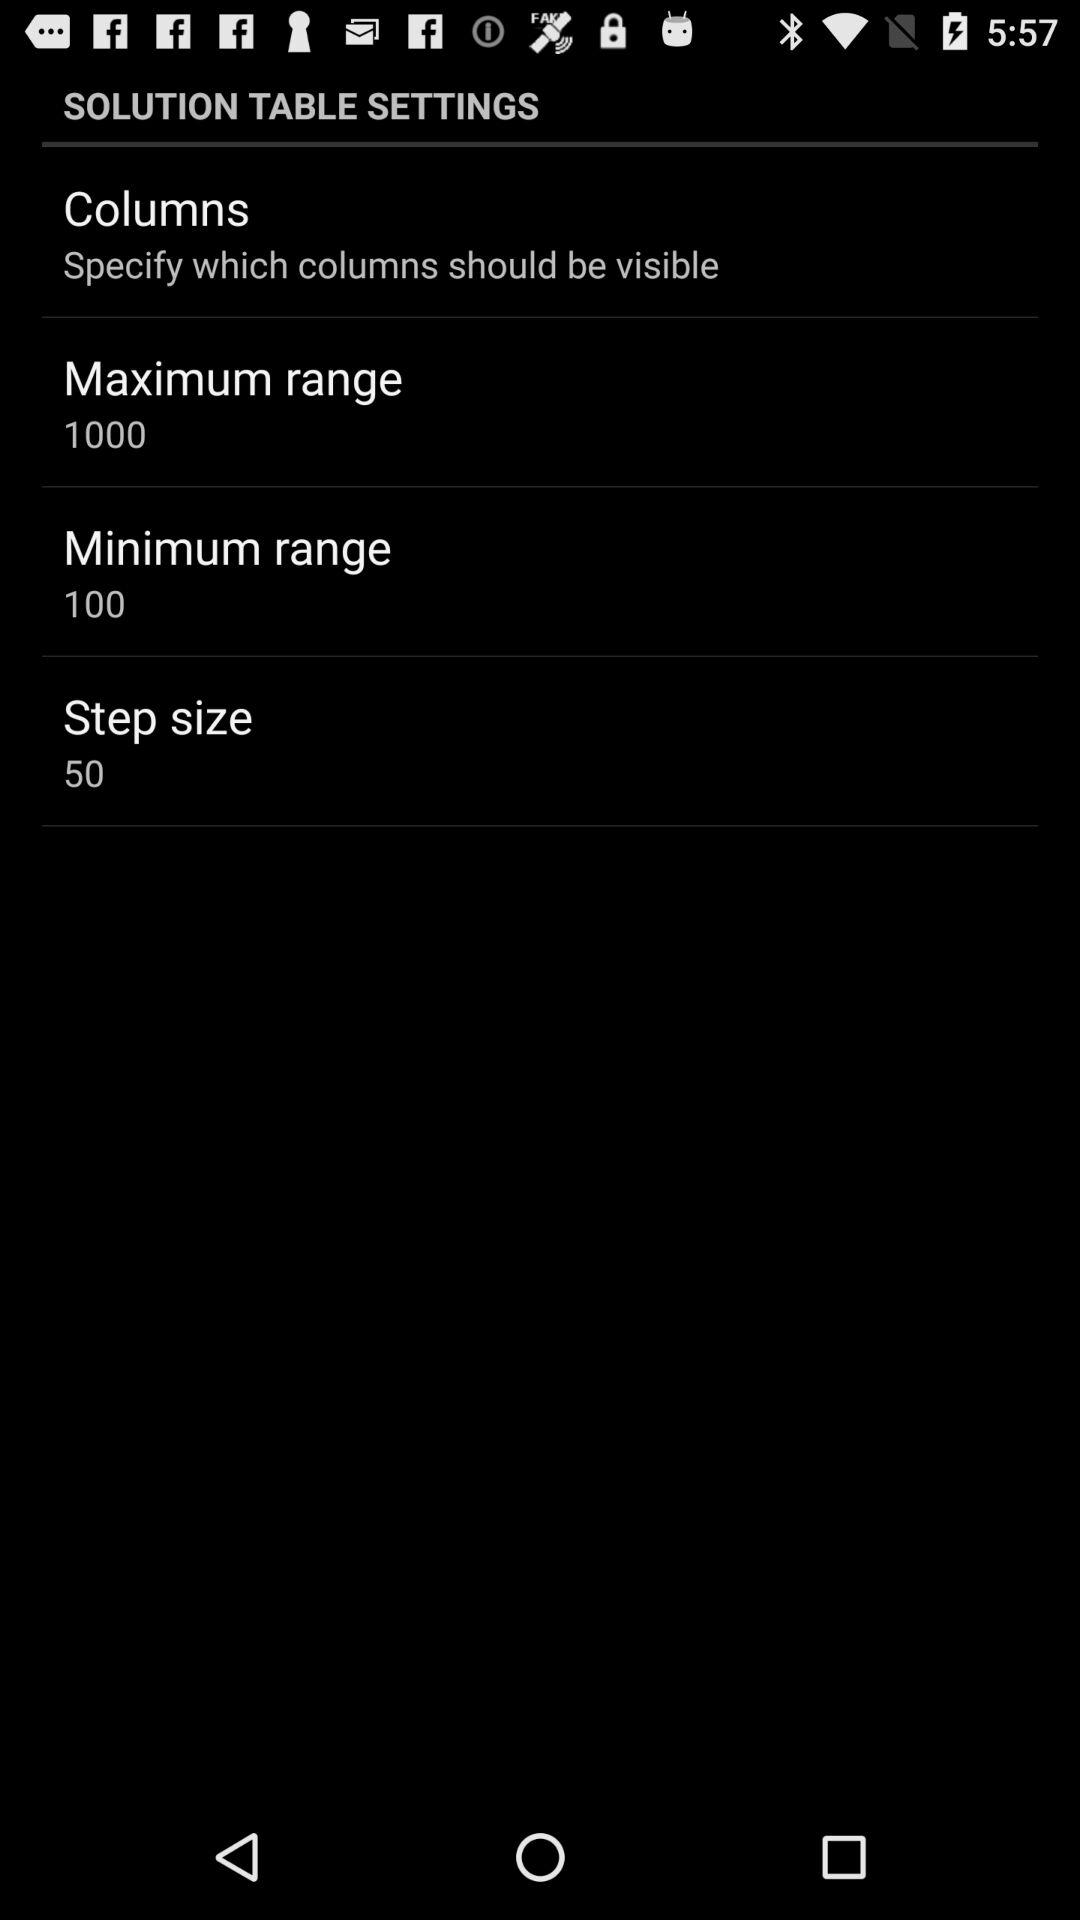What is the step size? The step size is 50. 